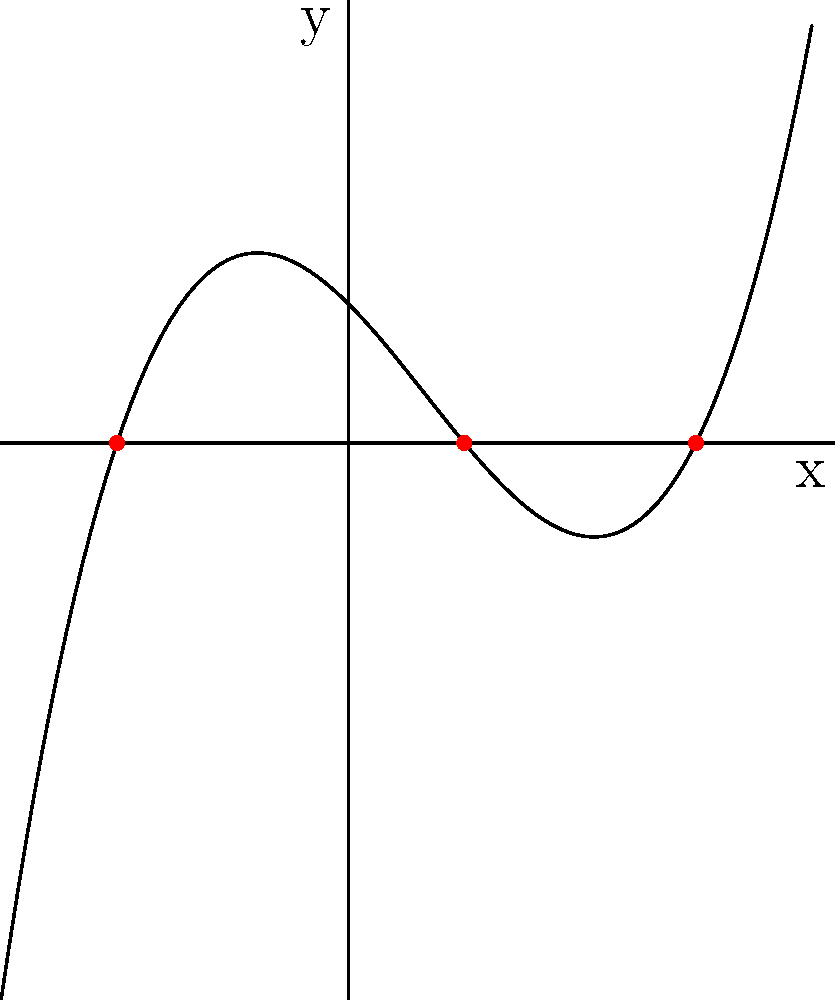As a novelist who appreciates their parent's help in reviewing manuscript drafts, imagine you're crafting a scene where a character is analyzing a cubic polynomial graph. The graph of a cubic polynomial $f(x)$ is shown above. What is the sum of the roots of this polynomial? Let's approach this step-by-step:

1) First, recall that for a cubic polynomial $f(x) = ax^3 + bx^2 + cx + d$, the sum of the roots is given by $-\frac{b}{a}$.

2) From the graph, we can see that the polynomial has three real roots. These are the x-intercepts of the graph.

3) The roots are clearly visible at $x = -2$, $x = 1$, and $x = 3$.

4) To find the sum of the roots, we simply add these values:

   $(-2) + 1 + 3 = 2$

5) This result, 2, should equal $-\frac{b}{a}$ for the polynomial.

6) As a novelist, you might use this mathematical insight to add depth to your character's analysis or problem-solving process in your story.
Answer: 2 